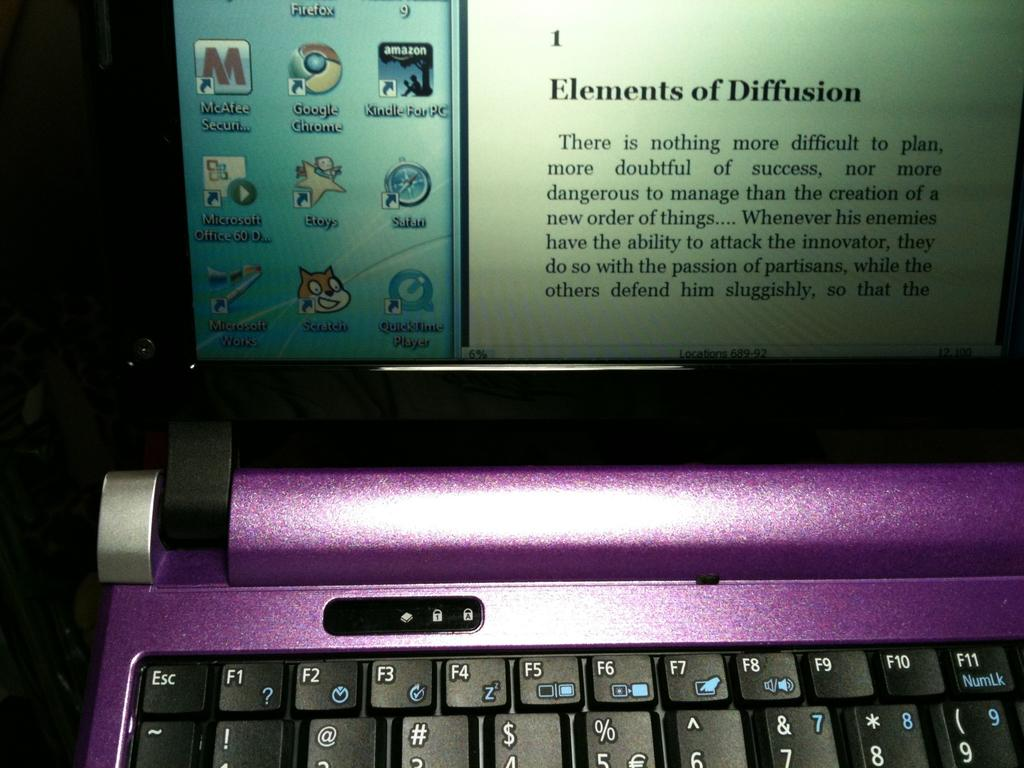<image>
Summarize the visual content of the image. A laptop screen shows the title of a book chapter about diffusion. 